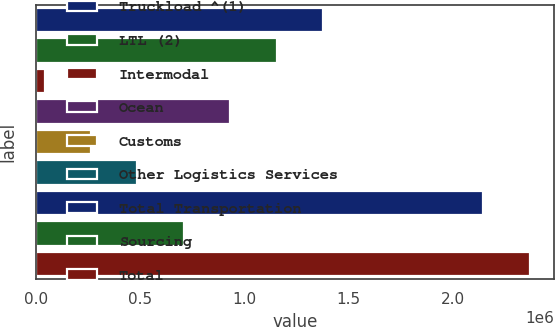Convert chart to OTSL. <chart><loc_0><loc_0><loc_500><loc_500><bar_chart><fcel>Truckload ^(1)<fcel>LTL (2)<fcel>Intermodal<fcel>Ocean<fcel>Customs<fcel>Other Logistics Services<fcel>Total Transportation<fcel>Sourcing<fcel>Total<nl><fcel>1.37751e+06<fcel>1.15477e+06<fcel>41054<fcel>932024<fcel>263797<fcel>486539<fcel>2.14751e+06<fcel>709282<fcel>2.37025e+06<nl></chart> 